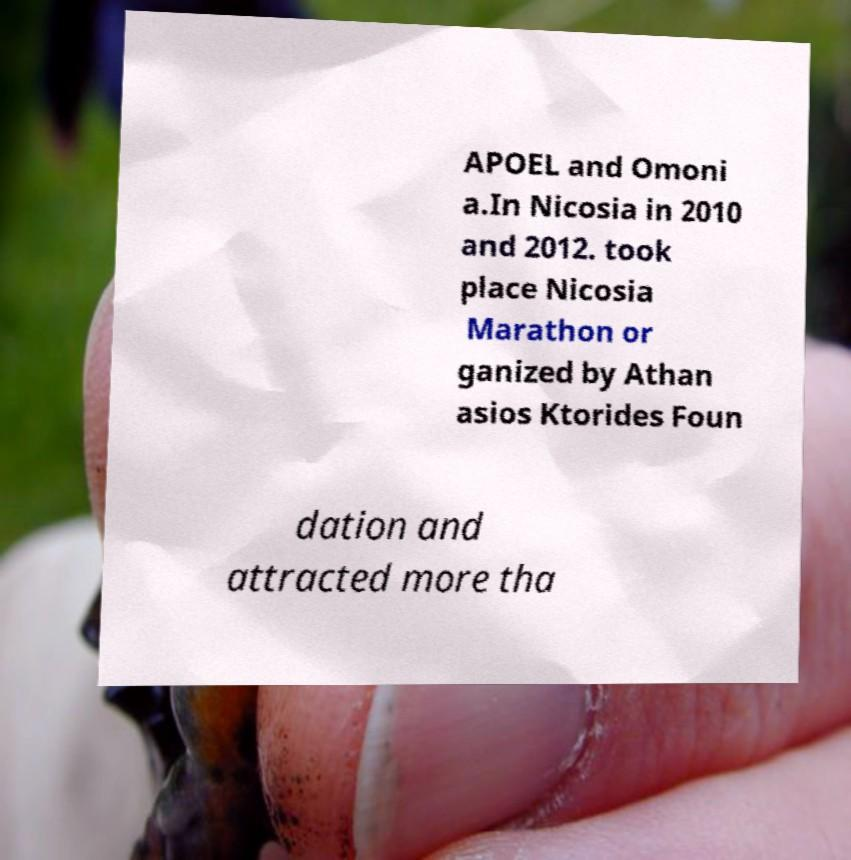I need the written content from this picture converted into text. Can you do that? APOEL and Omoni a.In Nicosia in 2010 and 2012. took place Nicosia Marathon or ganized by Athan asios Ktorides Foun dation and attracted more tha 